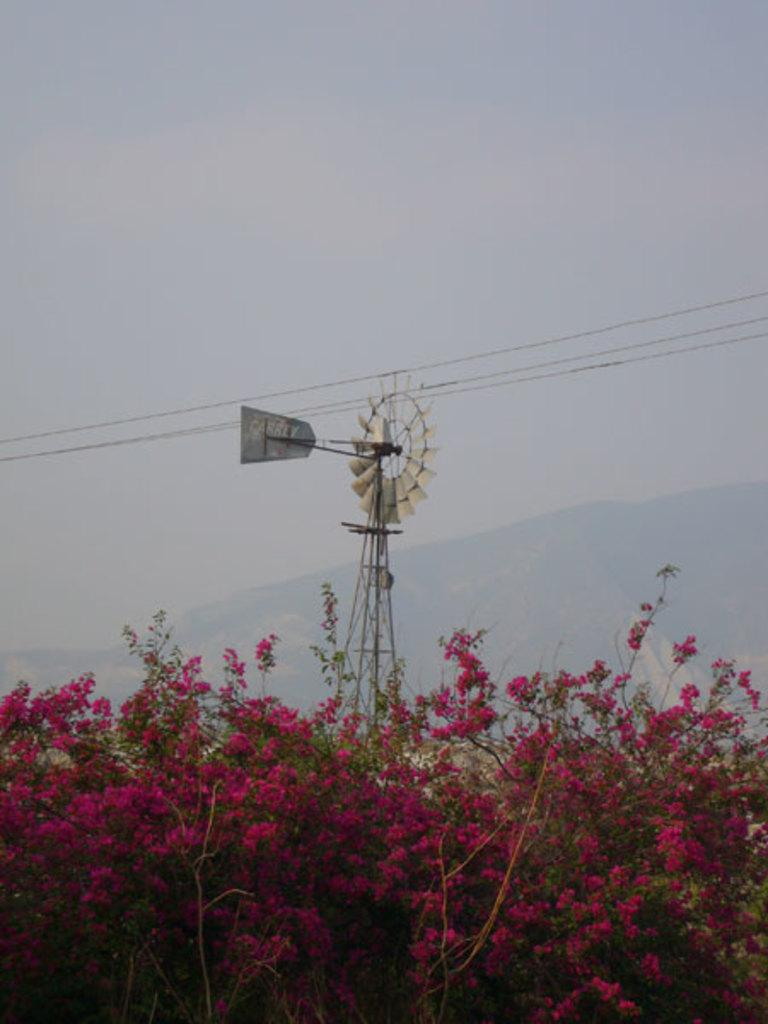What type of plants can be seen in the image? There are flowers in the image. What structure is present in the image? There is a windmill in the image. What else can be seen in the image besides the flowers and windmill? There are wires in the image. What is visible in the background of the image? The sky is visible in the background of the image. What type of cake is being served at the windmill in the image? There is no cake present in the image; it features flowers, a windmill, and wires. How many mittens can be seen on the flowers in the image? There are no mittens present in the image; it features flowers, a windmill, and wires. 